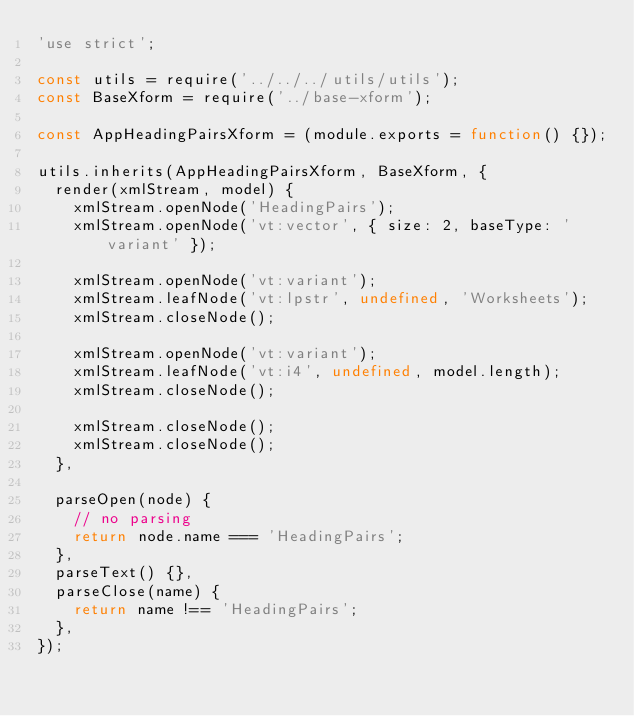Convert code to text. <code><loc_0><loc_0><loc_500><loc_500><_JavaScript_>'use strict';

const utils = require('../../../utils/utils');
const BaseXform = require('../base-xform');

const AppHeadingPairsXform = (module.exports = function() {});

utils.inherits(AppHeadingPairsXform, BaseXform, {
  render(xmlStream, model) {
    xmlStream.openNode('HeadingPairs');
    xmlStream.openNode('vt:vector', { size: 2, baseType: 'variant' });

    xmlStream.openNode('vt:variant');
    xmlStream.leafNode('vt:lpstr', undefined, 'Worksheets');
    xmlStream.closeNode();

    xmlStream.openNode('vt:variant');
    xmlStream.leafNode('vt:i4', undefined, model.length);
    xmlStream.closeNode();

    xmlStream.closeNode();
    xmlStream.closeNode();
  },

  parseOpen(node) {
    // no parsing
    return node.name === 'HeadingPairs';
  },
  parseText() {},
  parseClose(name) {
    return name !== 'HeadingPairs';
  },
});
</code> 